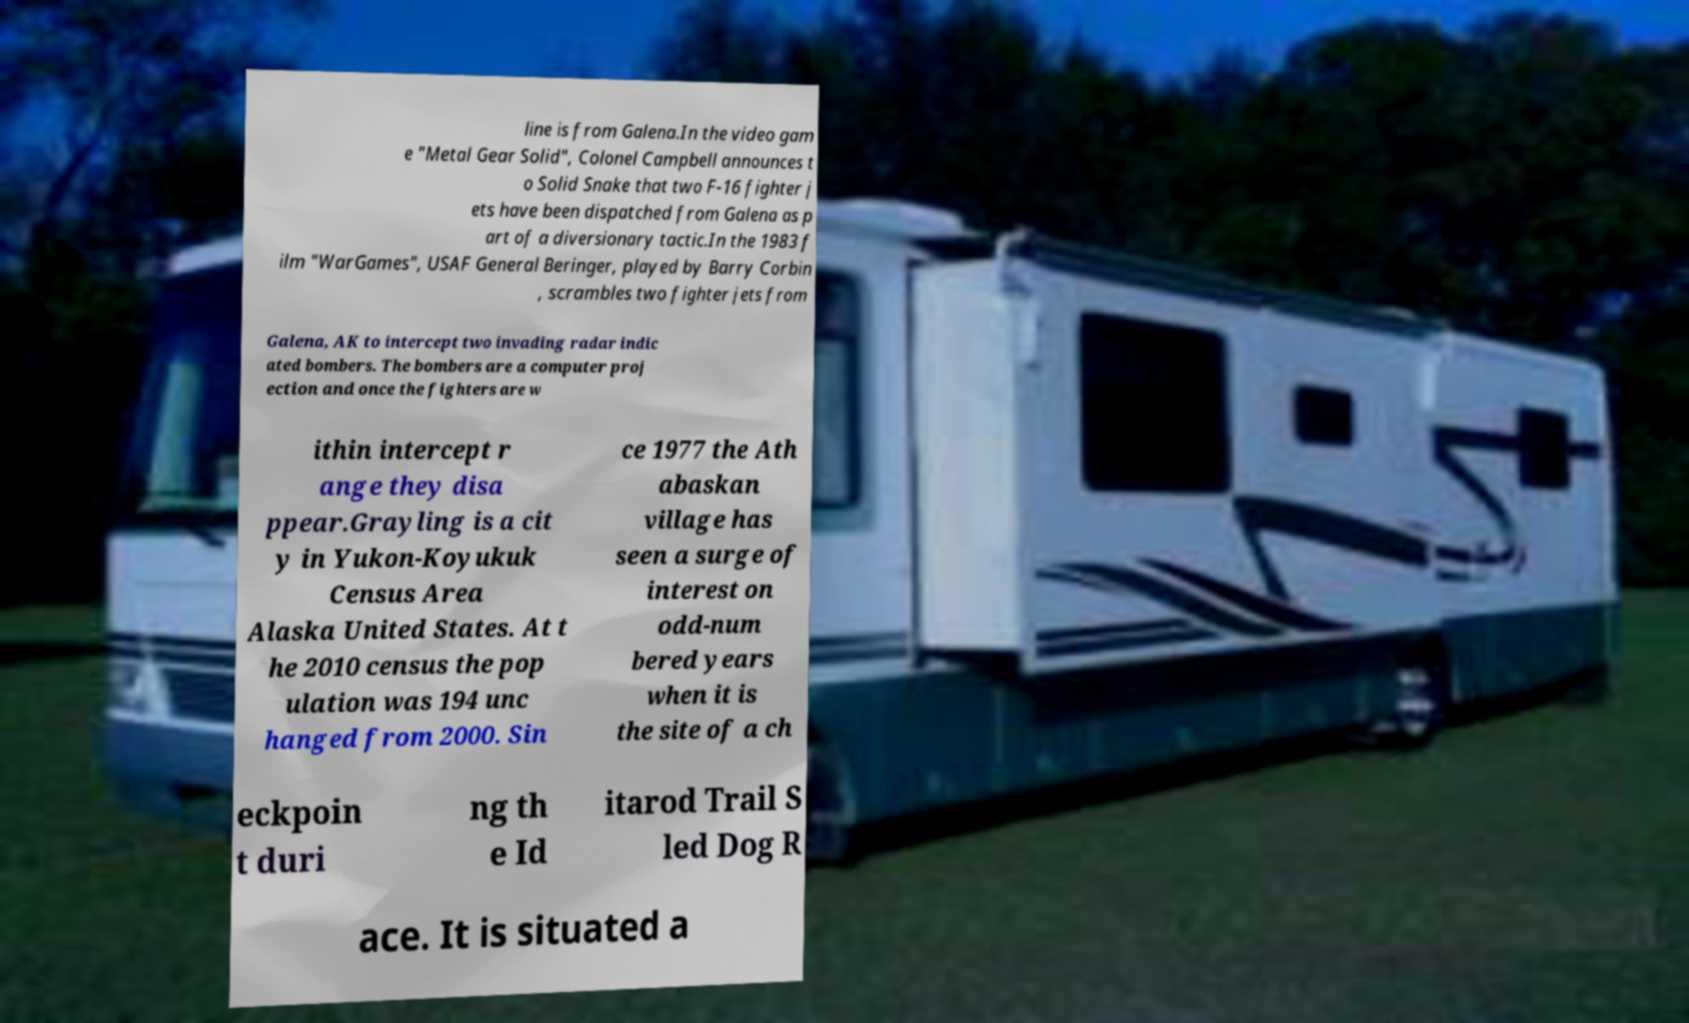Could you assist in decoding the text presented in this image and type it out clearly? line is from Galena.In the video gam e "Metal Gear Solid", Colonel Campbell announces t o Solid Snake that two F-16 fighter j ets have been dispatched from Galena as p art of a diversionary tactic.In the 1983 f ilm "WarGames", USAF General Beringer, played by Barry Corbin , scrambles two fighter jets from Galena, AK to intercept two invading radar indic ated bombers. The bombers are a computer proj ection and once the fighters are w ithin intercept r ange they disa ppear.Grayling is a cit y in Yukon-Koyukuk Census Area Alaska United States. At t he 2010 census the pop ulation was 194 unc hanged from 2000. Sin ce 1977 the Ath abaskan village has seen a surge of interest on odd-num bered years when it is the site of a ch eckpoin t duri ng th e Id itarod Trail S led Dog R ace. It is situated a 